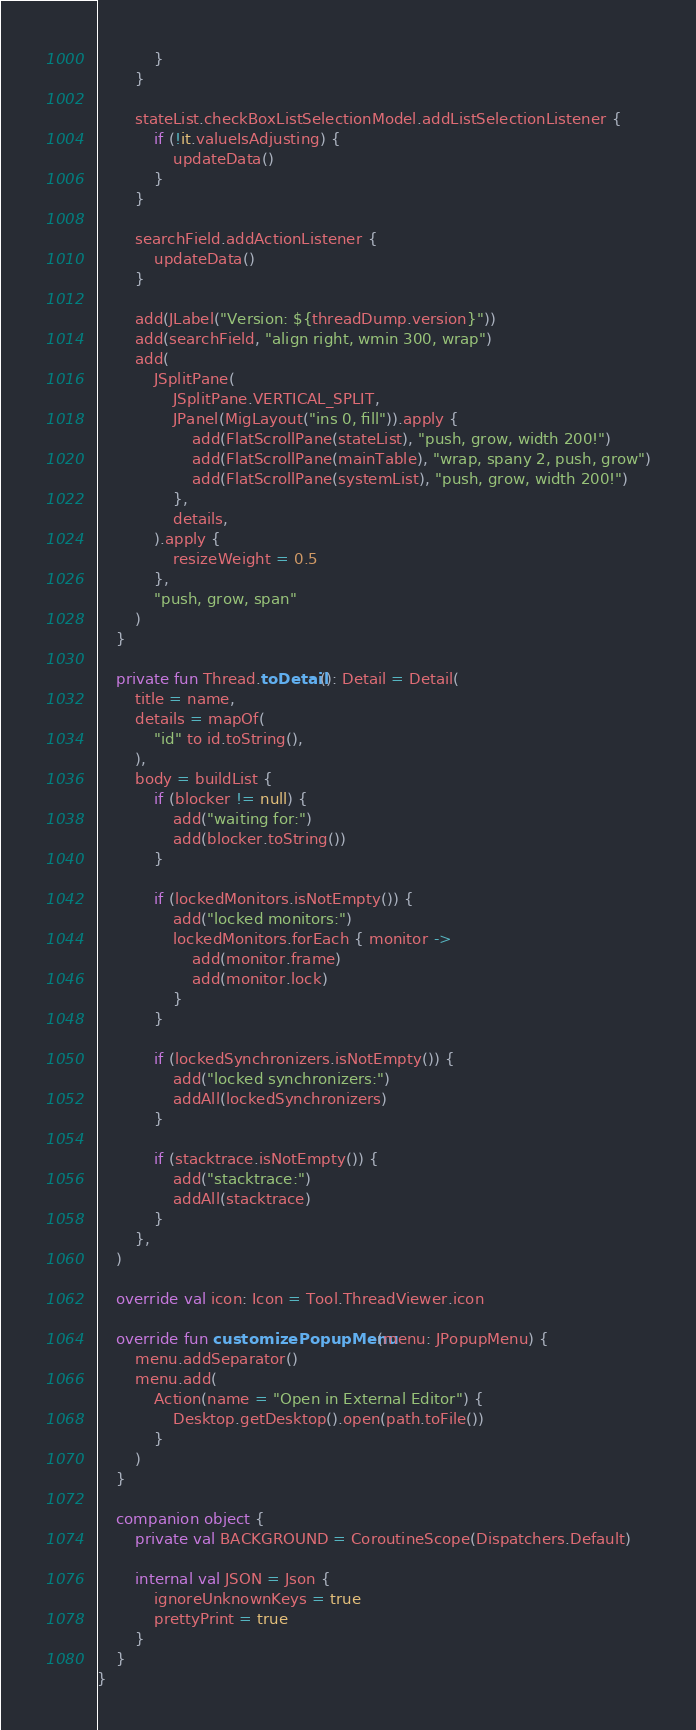Convert code to text. <code><loc_0><loc_0><loc_500><loc_500><_Kotlin_>            }
        }

        stateList.checkBoxListSelectionModel.addListSelectionListener {
            if (!it.valueIsAdjusting) {
                updateData()
            }
        }

        searchField.addActionListener {
            updateData()
        }

        add(JLabel("Version: ${threadDump.version}"))
        add(searchField, "align right, wmin 300, wrap")
        add(
            JSplitPane(
                JSplitPane.VERTICAL_SPLIT,
                JPanel(MigLayout("ins 0, fill")).apply {
                    add(FlatScrollPane(stateList), "push, grow, width 200!")
                    add(FlatScrollPane(mainTable), "wrap, spany 2, push, grow")
                    add(FlatScrollPane(systemList), "push, grow, width 200!")
                },
                details,
            ).apply {
                resizeWeight = 0.5
            },
            "push, grow, span"
        )
    }

    private fun Thread.toDetail(): Detail = Detail(
        title = name,
        details = mapOf(
            "id" to id.toString(),
        ),
        body = buildList {
            if (blocker != null) {
                add("waiting for:")
                add(blocker.toString())
            }

            if (lockedMonitors.isNotEmpty()) {
                add("locked monitors:")
                lockedMonitors.forEach { monitor ->
                    add(monitor.frame)
                    add(monitor.lock)
                }
            }

            if (lockedSynchronizers.isNotEmpty()) {
                add("locked synchronizers:")
                addAll(lockedSynchronizers)
            }

            if (stacktrace.isNotEmpty()) {
                add("stacktrace:")
                addAll(stacktrace)
            }
        },
    )

    override val icon: Icon = Tool.ThreadViewer.icon

    override fun customizePopupMenu(menu: JPopupMenu) {
        menu.addSeparator()
        menu.add(
            Action(name = "Open in External Editor") {
                Desktop.getDesktop().open(path.toFile())
            }
        )
    }

    companion object {
        private val BACKGROUND = CoroutineScope(Dispatchers.Default)

        internal val JSON = Json {
            ignoreUnknownKeys = true
            prettyPrint = true
        }
    }
}
</code> 